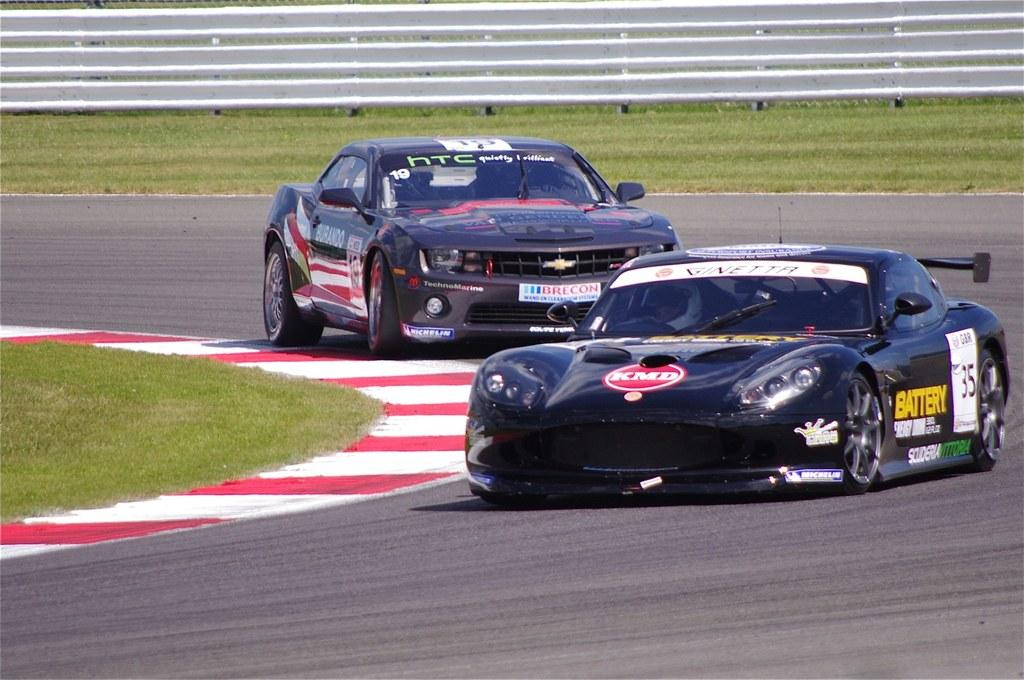What can be seen on the road in the image? There are vehicles on the road in the image. What is visible in the background of the image? There is a fence in the background of the image. What part of the environment is visible in the image? The ground is visible in the image. What type of honey is being collected by the tooth in the image? There is no honey or tooth present in the image. 